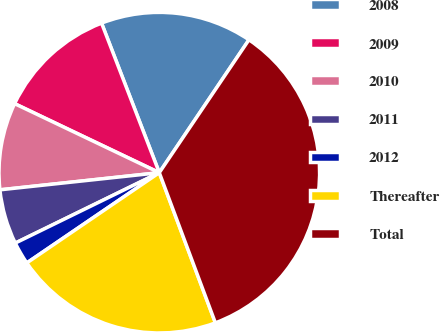Convert chart to OTSL. <chart><loc_0><loc_0><loc_500><loc_500><pie_chart><fcel>2008<fcel>2009<fcel>2010<fcel>2011<fcel>2012<fcel>Thereafter<fcel>Total<nl><fcel>15.31%<fcel>12.05%<fcel>8.79%<fcel>5.53%<fcel>2.28%<fcel>21.17%<fcel>34.86%<nl></chart> 